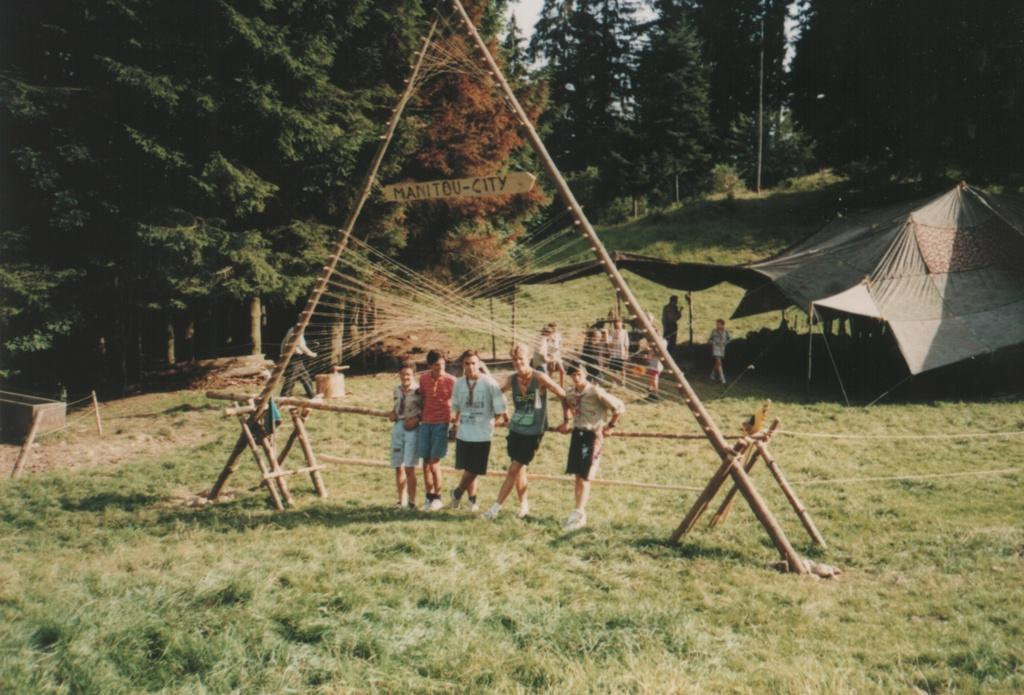How many people are present in the image? There are 5 people in the image. What are the people doing in the image? The people are standing near an A-shaped pole. Where is the pole located? The pole is on a grass field. What can be seen in the background of the image? There is a big tent in the background of the image, and trees are visible around the tent. Are there any people in the trees? Yes, there are people in the trees. What type of insect can be seen crawling on the pocket of one of the people in the image? There is no insect visible on anyone's pocket in the image. What is the range of the pole in the image? The range of the pole cannot be determined from the image, as it is a stationary object and does not have a range. 